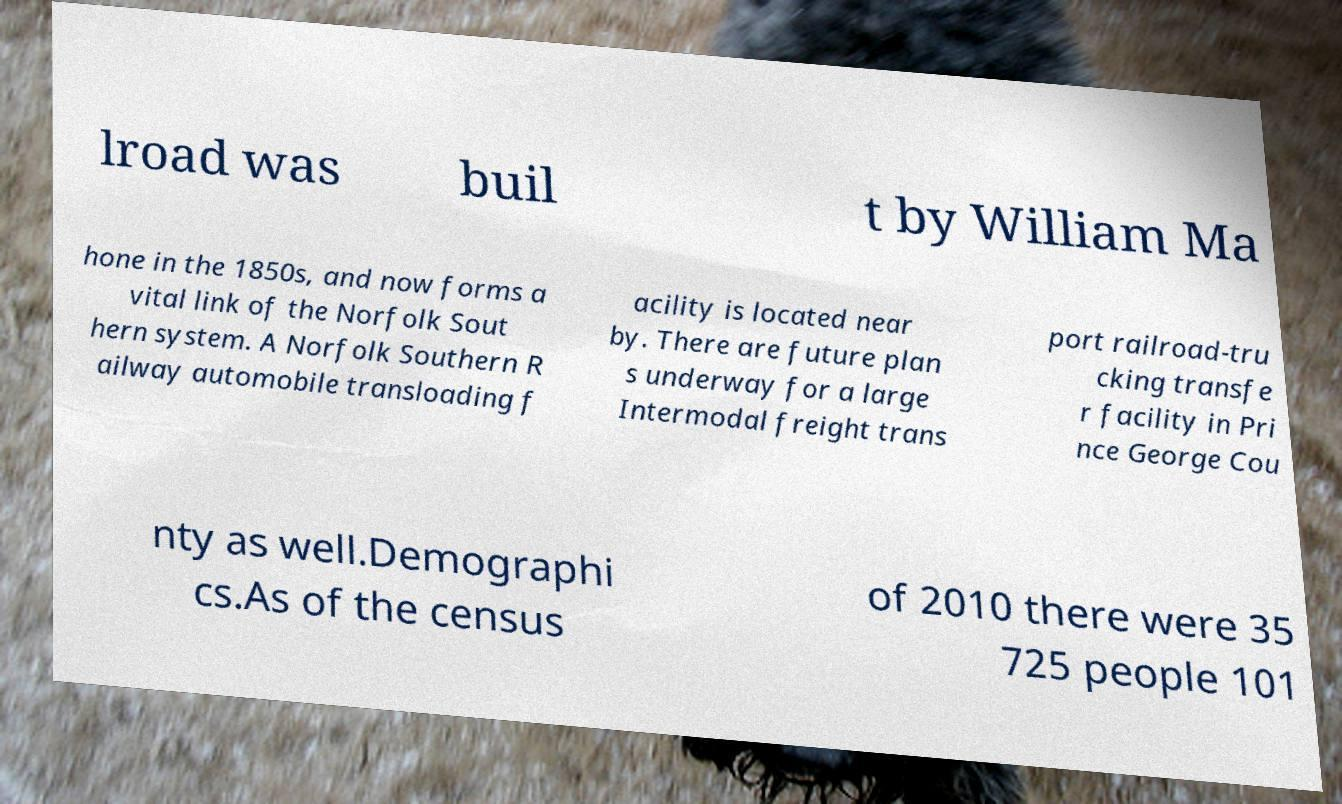Could you extract and type out the text from this image? lroad was buil t by William Ma hone in the 1850s, and now forms a vital link of the Norfolk Sout hern system. A Norfolk Southern R ailway automobile transloading f acility is located near by. There are future plan s underway for a large Intermodal freight trans port railroad-tru cking transfe r facility in Pri nce George Cou nty as well.Demographi cs.As of the census of 2010 there were 35 725 people 101 